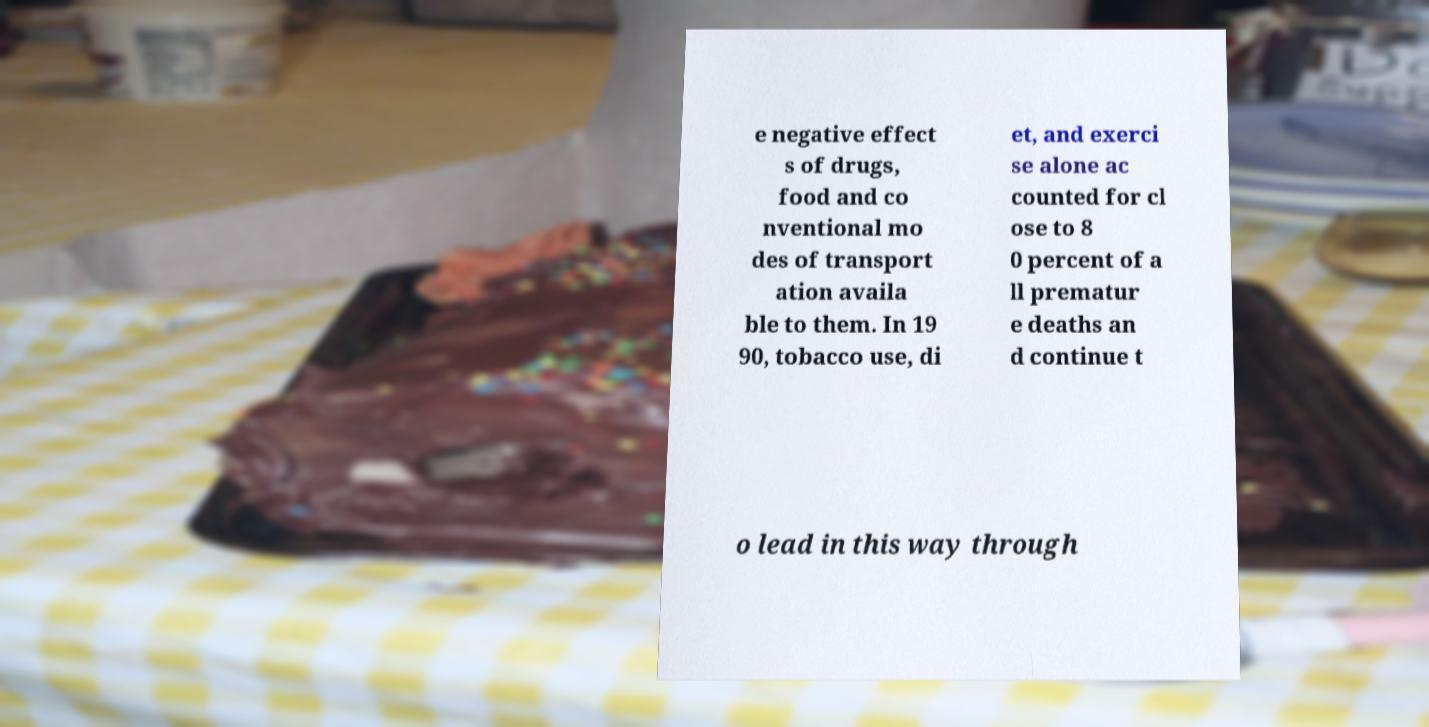Please read and relay the text visible in this image. What does it say? e negative effect s of drugs, food and co nventional mo des of transport ation availa ble to them. In 19 90, tobacco use, di et, and exerci se alone ac counted for cl ose to 8 0 percent of a ll prematur e deaths an d continue t o lead in this way through 